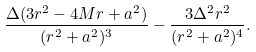<formula> <loc_0><loc_0><loc_500><loc_500>\frac { \Delta ( 3 r ^ { 2 } - 4 M r + a ^ { 2 } ) } { ( r ^ { 2 } + a ^ { 2 } ) ^ { 3 } } - \frac { 3 \Delta ^ { 2 } r ^ { 2 } } { ( r ^ { 2 } + a ^ { 2 } ) ^ { 4 } } .</formula> 